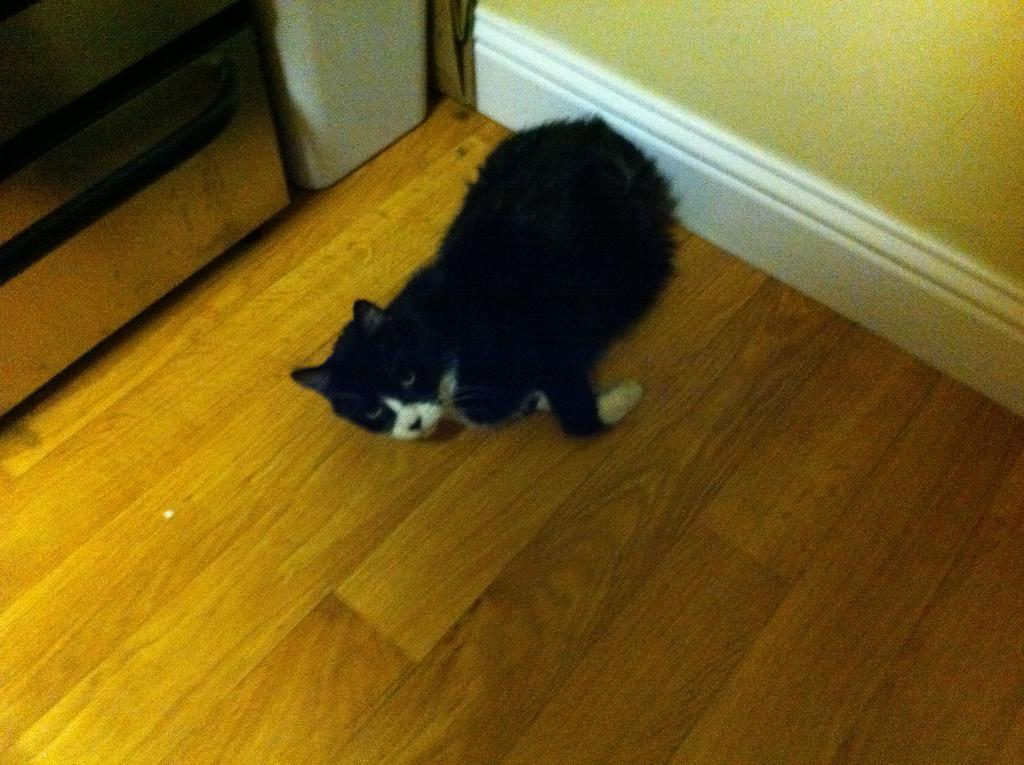What type of animal is in the image? There is a black color cat in the image. What is the cat standing on? The cat is on a wooden surface. What can be seen in the background of the image? There is a wall in the background of the image. What type of nerve can be seen in the image? There is no nerve present in the image; it features a black color cat on a wooden surface with a wall in the background. 